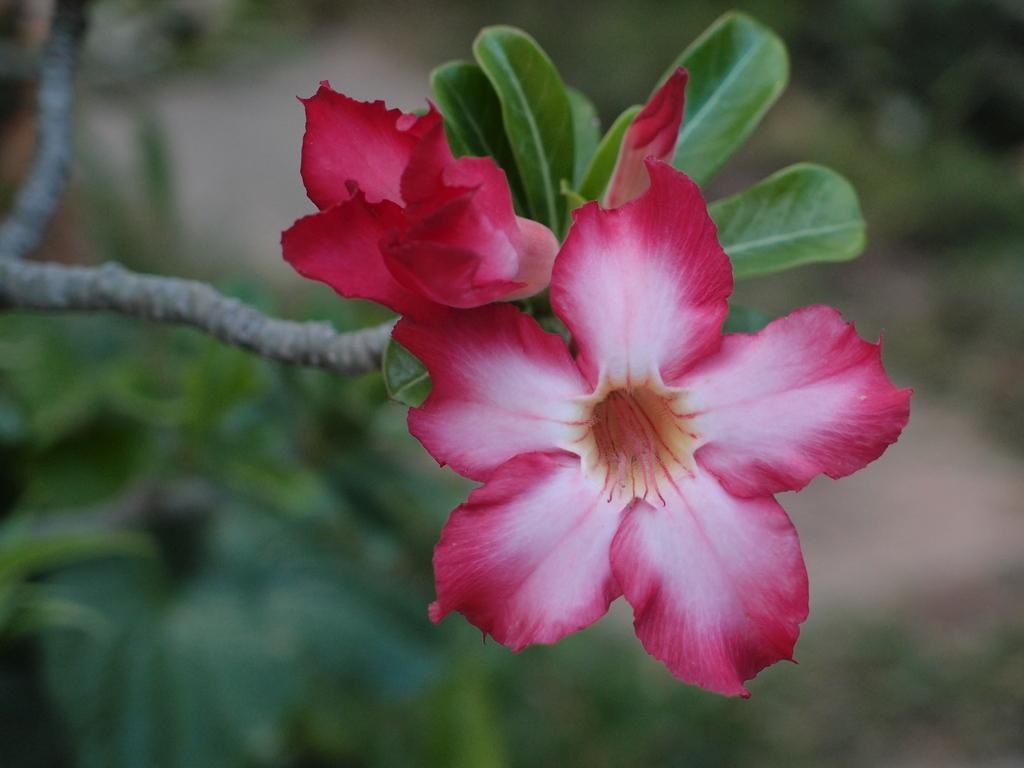What type of plant life can be seen in the image? There are flowers and leaves in the image. Can you describe the flowers in the image? Unfortunately, the facts provided do not give specific details about the flowers. Are there any other elements in the image besides the flowers and leaves? The facts provided do not mention any other elements in the image. What type of fiction is being read by the flowers in the image? There are no people or books present in the image, so it is not possible to determine if any fiction is being read by the flowers. 